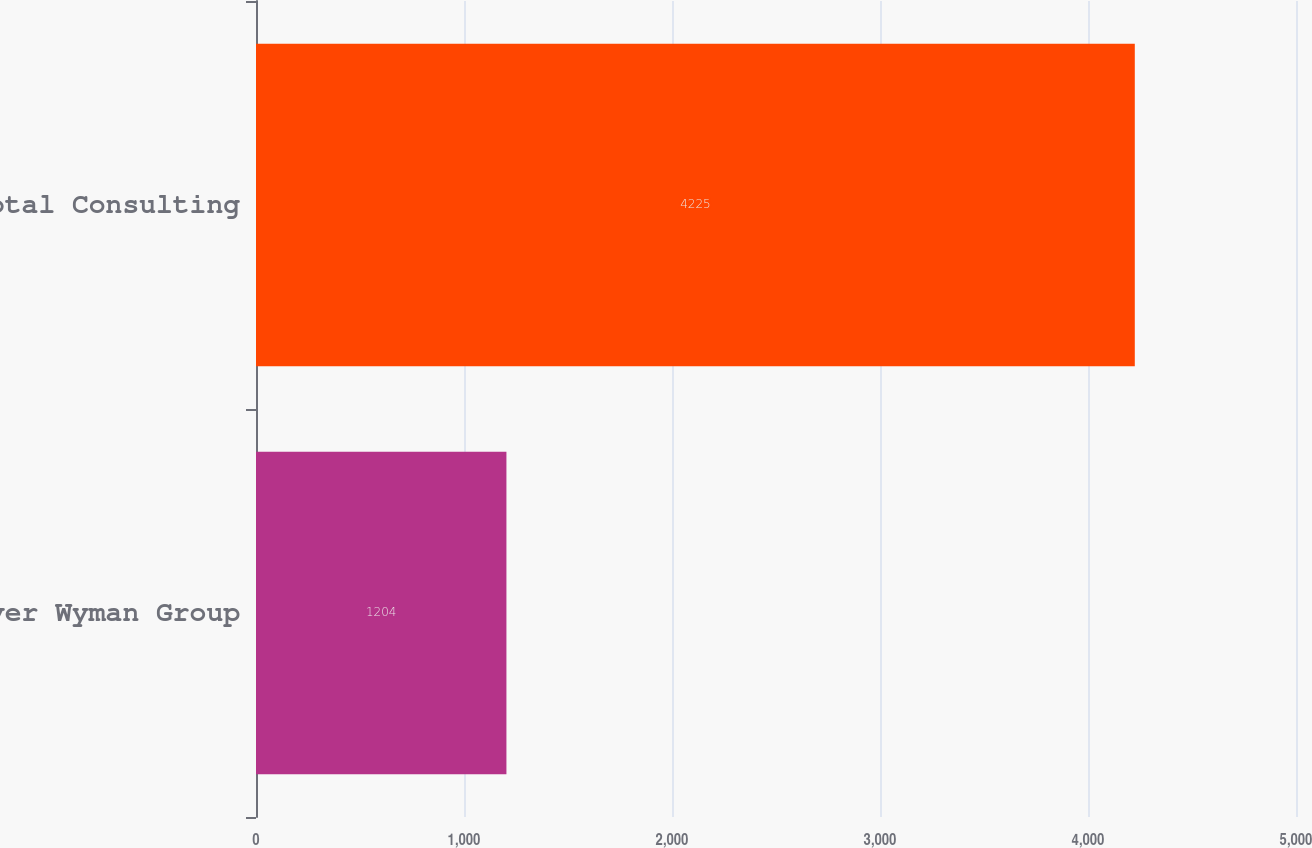<chart> <loc_0><loc_0><loc_500><loc_500><bar_chart><fcel>Oliver Wyman Group<fcel>Total Consulting<nl><fcel>1204<fcel>4225<nl></chart> 